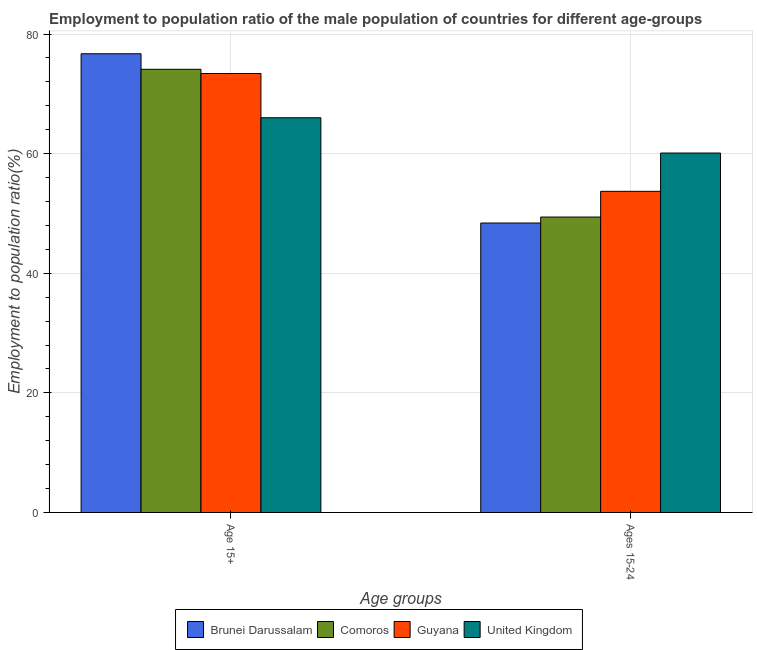How many different coloured bars are there?
Give a very brief answer. 4. Are the number of bars per tick equal to the number of legend labels?
Keep it short and to the point. Yes. How many bars are there on the 2nd tick from the left?
Provide a succinct answer. 4. How many bars are there on the 1st tick from the right?
Ensure brevity in your answer.  4. What is the label of the 1st group of bars from the left?
Your answer should be very brief. Age 15+. What is the employment to population ratio(age 15+) in Comoros?
Your answer should be compact. 74.1. Across all countries, what is the maximum employment to population ratio(age 15-24)?
Make the answer very short. 60.1. Across all countries, what is the minimum employment to population ratio(age 15-24)?
Your answer should be compact. 48.4. In which country was the employment to population ratio(age 15+) minimum?
Your response must be concise. United Kingdom. What is the total employment to population ratio(age 15-24) in the graph?
Provide a succinct answer. 211.6. What is the difference between the employment to population ratio(age 15+) in United Kingdom and that in Comoros?
Make the answer very short. -8.1. What is the difference between the employment to population ratio(age 15+) in Brunei Darussalam and the employment to population ratio(age 15-24) in Comoros?
Your answer should be very brief. 27.3. What is the average employment to population ratio(age 15+) per country?
Offer a terse response. 72.55. What is the difference between the employment to population ratio(age 15+) and employment to population ratio(age 15-24) in Comoros?
Keep it short and to the point. 24.7. In how many countries, is the employment to population ratio(age 15-24) greater than 68 %?
Your answer should be very brief. 0. What is the ratio of the employment to population ratio(age 15+) in Guyana to that in Brunei Darussalam?
Provide a succinct answer. 0.96. What does the 2nd bar from the left in Age 15+ represents?
Give a very brief answer. Comoros. What does the 3rd bar from the right in Ages 15-24 represents?
Your answer should be compact. Comoros. Are all the bars in the graph horizontal?
Keep it short and to the point. No. What is the difference between two consecutive major ticks on the Y-axis?
Your answer should be compact. 20. Does the graph contain any zero values?
Your answer should be very brief. No. Does the graph contain grids?
Provide a succinct answer. Yes. How are the legend labels stacked?
Provide a short and direct response. Horizontal. What is the title of the graph?
Ensure brevity in your answer.  Employment to population ratio of the male population of countries for different age-groups. What is the label or title of the X-axis?
Ensure brevity in your answer.  Age groups. What is the Employment to population ratio(%) of Brunei Darussalam in Age 15+?
Your answer should be very brief. 76.7. What is the Employment to population ratio(%) in Comoros in Age 15+?
Offer a very short reply. 74.1. What is the Employment to population ratio(%) in Guyana in Age 15+?
Offer a terse response. 73.4. What is the Employment to population ratio(%) in Brunei Darussalam in Ages 15-24?
Make the answer very short. 48.4. What is the Employment to population ratio(%) of Comoros in Ages 15-24?
Your response must be concise. 49.4. What is the Employment to population ratio(%) of Guyana in Ages 15-24?
Your answer should be compact. 53.7. What is the Employment to population ratio(%) of United Kingdom in Ages 15-24?
Provide a short and direct response. 60.1. Across all Age groups, what is the maximum Employment to population ratio(%) of Brunei Darussalam?
Keep it short and to the point. 76.7. Across all Age groups, what is the maximum Employment to population ratio(%) of Comoros?
Keep it short and to the point. 74.1. Across all Age groups, what is the maximum Employment to population ratio(%) in Guyana?
Your answer should be compact. 73.4. Across all Age groups, what is the minimum Employment to population ratio(%) of Brunei Darussalam?
Your response must be concise. 48.4. Across all Age groups, what is the minimum Employment to population ratio(%) in Comoros?
Ensure brevity in your answer.  49.4. Across all Age groups, what is the minimum Employment to population ratio(%) in Guyana?
Your answer should be very brief. 53.7. Across all Age groups, what is the minimum Employment to population ratio(%) in United Kingdom?
Provide a succinct answer. 60.1. What is the total Employment to population ratio(%) of Brunei Darussalam in the graph?
Your answer should be compact. 125.1. What is the total Employment to population ratio(%) in Comoros in the graph?
Offer a very short reply. 123.5. What is the total Employment to population ratio(%) in Guyana in the graph?
Ensure brevity in your answer.  127.1. What is the total Employment to population ratio(%) of United Kingdom in the graph?
Provide a succinct answer. 126.1. What is the difference between the Employment to population ratio(%) in Brunei Darussalam in Age 15+ and that in Ages 15-24?
Ensure brevity in your answer.  28.3. What is the difference between the Employment to population ratio(%) in Comoros in Age 15+ and that in Ages 15-24?
Provide a succinct answer. 24.7. What is the difference between the Employment to population ratio(%) in Guyana in Age 15+ and that in Ages 15-24?
Provide a succinct answer. 19.7. What is the difference between the Employment to population ratio(%) of United Kingdom in Age 15+ and that in Ages 15-24?
Ensure brevity in your answer.  5.9. What is the difference between the Employment to population ratio(%) in Brunei Darussalam in Age 15+ and the Employment to population ratio(%) in Comoros in Ages 15-24?
Your answer should be compact. 27.3. What is the difference between the Employment to population ratio(%) in Brunei Darussalam in Age 15+ and the Employment to population ratio(%) in Guyana in Ages 15-24?
Provide a succinct answer. 23. What is the difference between the Employment to population ratio(%) in Brunei Darussalam in Age 15+ and the Employment to population ratio(%) in United Kingdom in Ages 15-24?
Ensure brevity in your answer.  16.6. What is the difference between the Employment to population ratio(%) in Comoros in Age 15+ and the Employment to population ratio(%) in Guyana in Ages 15-24?
Keep it short and to the point. 20.4. What is the difference between the Employment to population ratio(%) of Guyana in Age 15+ and the Employment to population ratio(%) of United Kingdom in Ages 15-24?
Give a very brief answer. 13.3. What is the average Employment to population ratio(%) in Brunei Darussalam per Age groups?
Your response must be concise. 62.55. What is the average Employment to population ratio(%) in Comoros per Age groups?
Your answer should be very brief. 61.75. What is the average Employment to population ratio(%) of Guyana per Age groups?
Your response must be concise. 63.55. What is the average Employment to population ratio(%) of United Kingdom per Age groups?
Offer a very short reply. 63.05. What is the difference between the Employment to population ratio(%) in Brunei Darussalam and Employment to population ratio(%) in Guyana in Age 15+?
Your answer should be compact. 3.3. What is the difference between the Employment to population ratio(%) in Brunei Darussalam and Employment to population ratio(%) in United Kingdom in Age 15+?
Provide a short and direct response. 10.7. What is the difference between the Employment to population ratio(%) in Comoros and Employment to population ratio(%) in Guyana in Age 15+?
Keep it short and to the point. 0.7. What is the difference between the Employment to population ratio(%) in Brunei Darussalam and Employment to population ratio(%) in Guyana in Ages 15-24?
Your answer should be very brief. -5.3. What is the difference between the Employment to population ratio(%) of Comoros and Employment to population ratio(%) of United Kingdom in Ages 15-24?
Keep it short and to the point. -10.7. What is the ratio of the Employment to population ratio(%) in Brunei Darussalam in Age 15+ to that in Ages 15-24?
Give a very brief answer. 1.58. What is the ratio of the Employment to population ratio(%) of Comoros in Age 15+ to that in Ages 15-24?
Your response must be concise. 1.5. What is the ratio of the Employment to population ratio(%) in Guyana in Age 15+ to that in Ages 15-24?
Give a very brief answer. 1.37. What is the ratio of the Employment to population ratio(%) of United Kingdom in Age 15+ to that in Ages 15-24?
Give a very brief answer. 1.1. What is the difference between the highest and the second highest Employment to population ratio(%) in Brunei Darussalam?
Give a very brief answer. 28.3. What is the difference between the highest and the second highest Employment to population ratio(%) in Comoros?
Your answer should be compact. 24.7. What is the difference between the highest and the lowest Employment to population ratio(%) of Brunei Darussalam?
Provide a short and direct response. 28.3. What is the difference between the highest and the lowest Employment to population ratio(%) of Comoros?
Your answer should be compact. 24.7. What is the difference between the highest and the lowest Employment to population ratio(%) of Guyana?
Your answer should be compact. 19.7. 